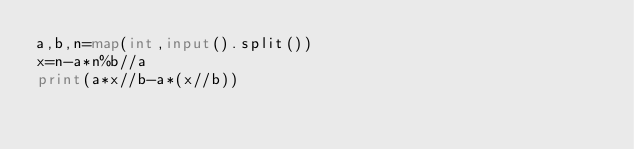Convert code to text. <code><loc_0><loc_0><loc_500><loc_500><_Python_>a,b,n=map(int,input().split())
x=n-a*n%b//a
print(a*x//b-a*(x//b))</code> 